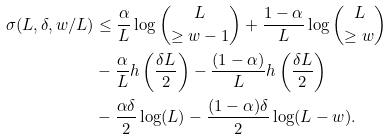Convert formula to latex. <formula><loc_0><loc_0><loc_500><loc_500>\sigma ( L , \delta , w / L ) & \leq \frac { \alpha } { L } \log \binom { L } { \geq w - 1 } + \frac { 1 - \alpha } { L } \log \binom { L } { \geq w } \\ & - \frac { \alpha } { L } h \left ( \frac { \delta L } { 2 } \right ) - \frac { ( 1 - \alpha ) } { L } h \left ( \frac { \delta L } { 2 } \right ) \\ & - \frac { \alpha \delta } { 2 } \log ( L ) - \frac { ( 1 - \alpha ) \delta } { 2 } \log ( L - w ) .</formula> 